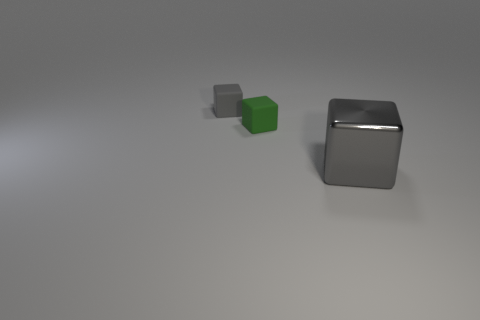Add 2 small green matte things. How many objects exist? 5 Add 1 big blocks. How many big blocks are left? 2 Add 1 small green spheres. How many small green spheres exist? 1 Subtract 0 yellow cubes. How many objects are left? 3 Subtract all gray shiny cubes. Subtract all small things. How many objects are left? 0 